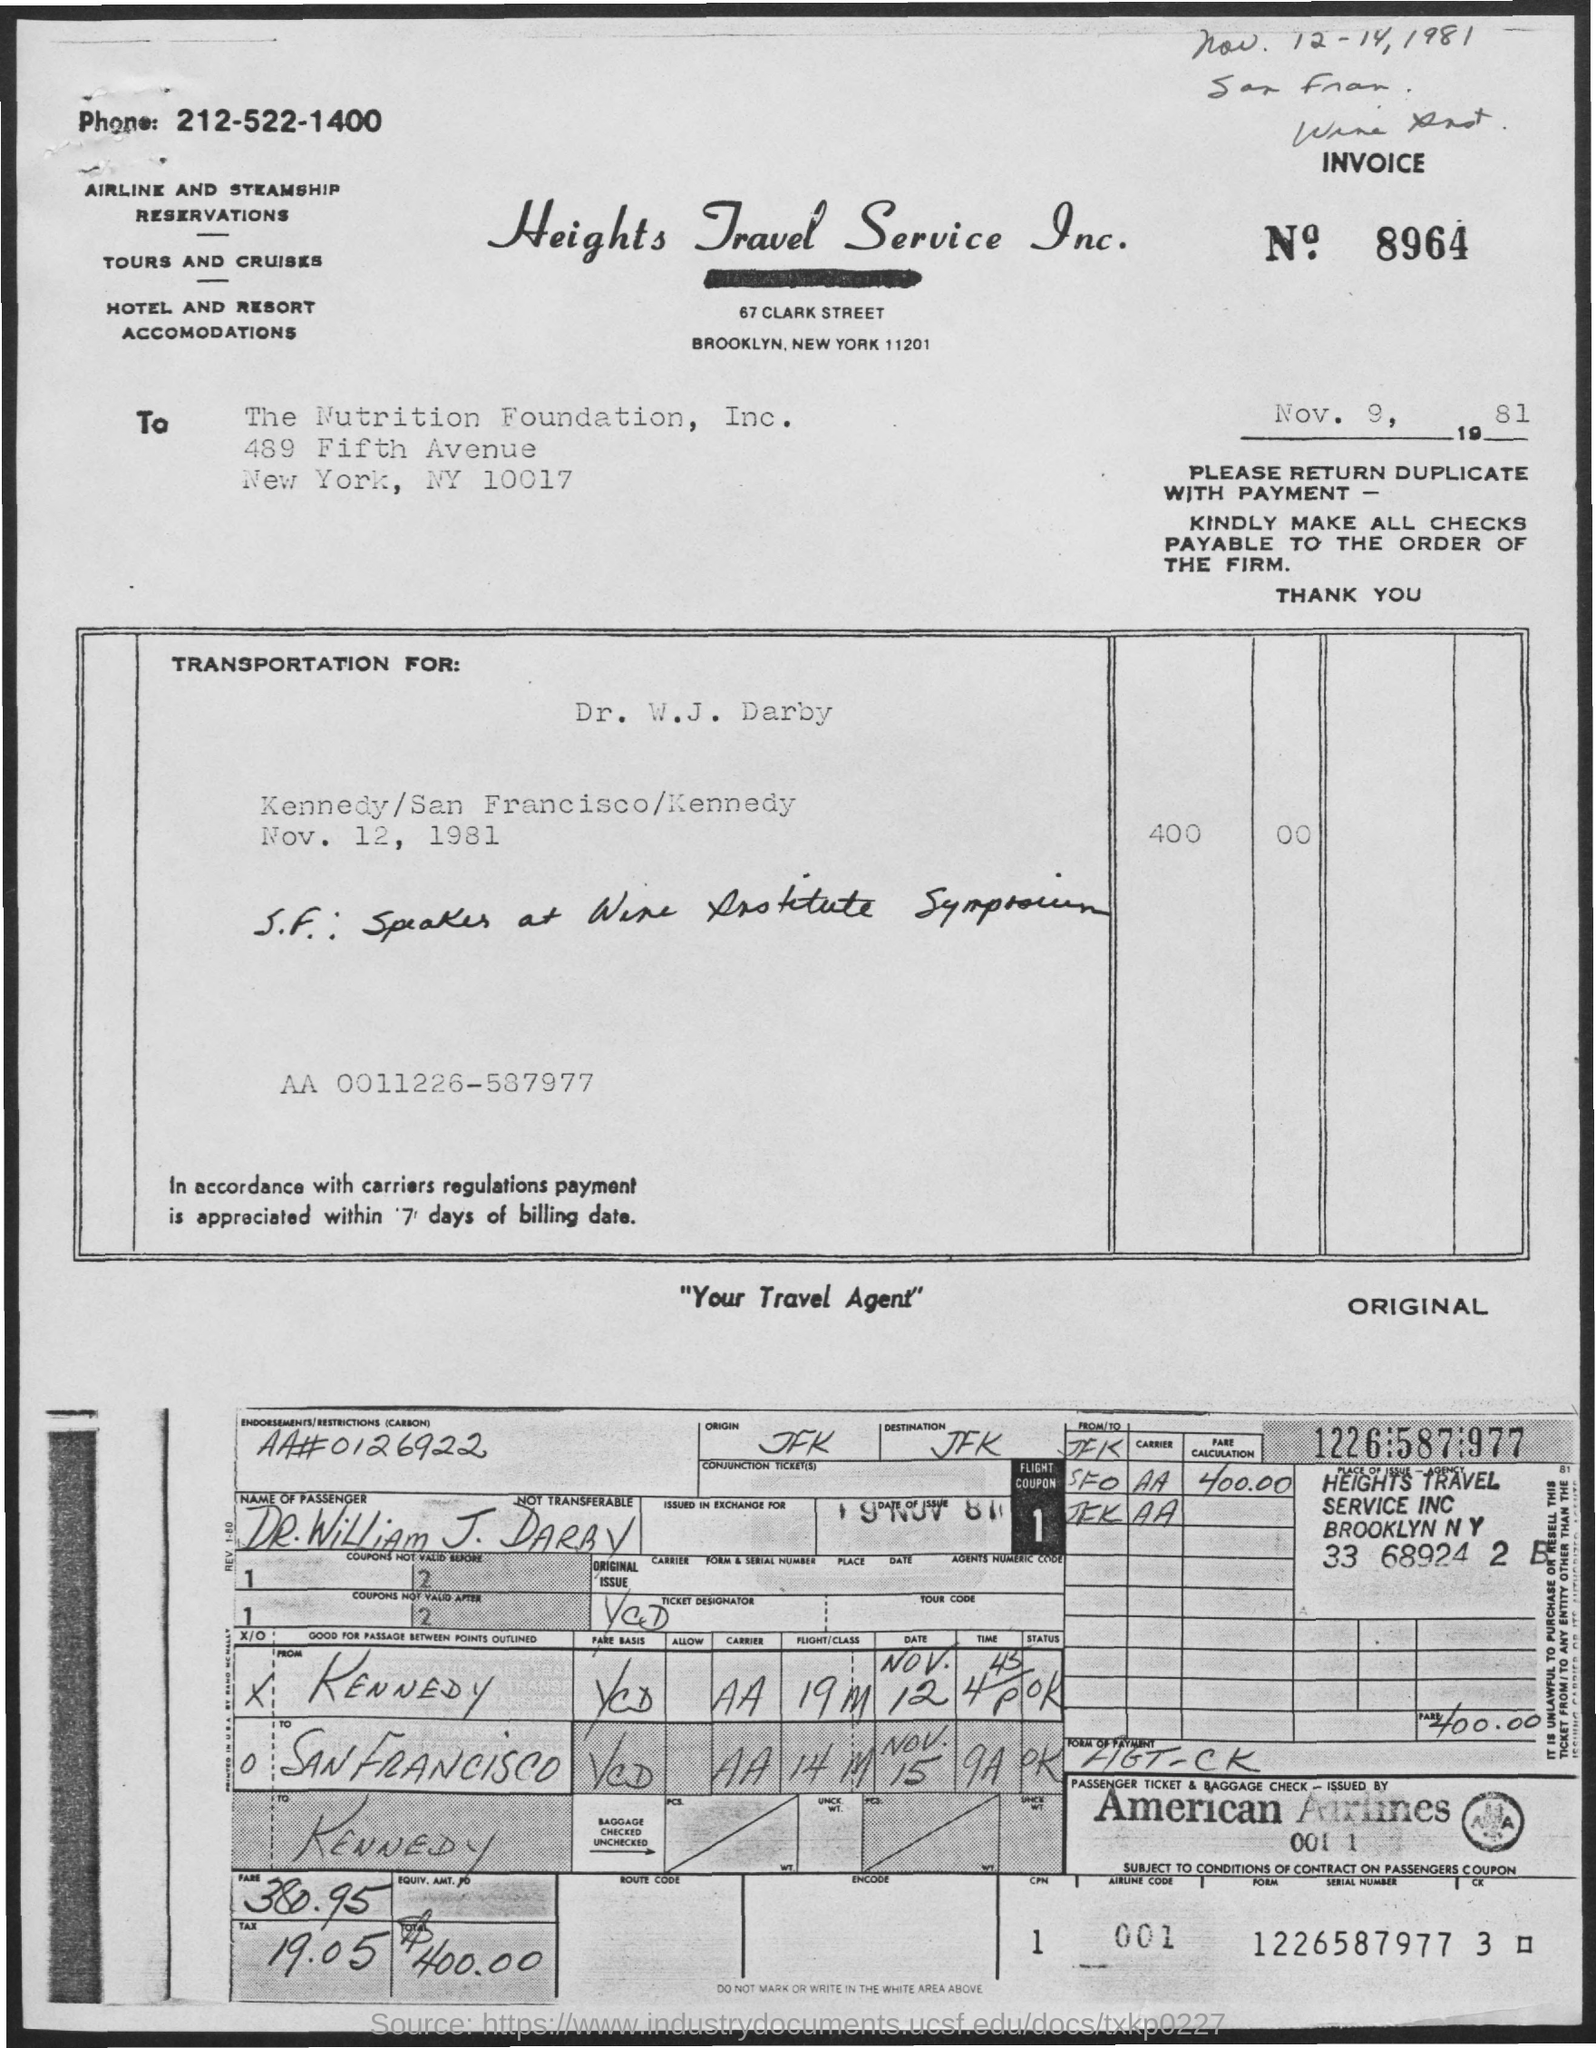What is the Invoice No.?
Your response must be concise. 8964. What is the date below the invoice number?
Your answer should be compact. Nov. 9, 1981. What is the tax?
Your answer should be very brief. 19.05. What is the serial number?
Your answer should be compact. 1226587977. 